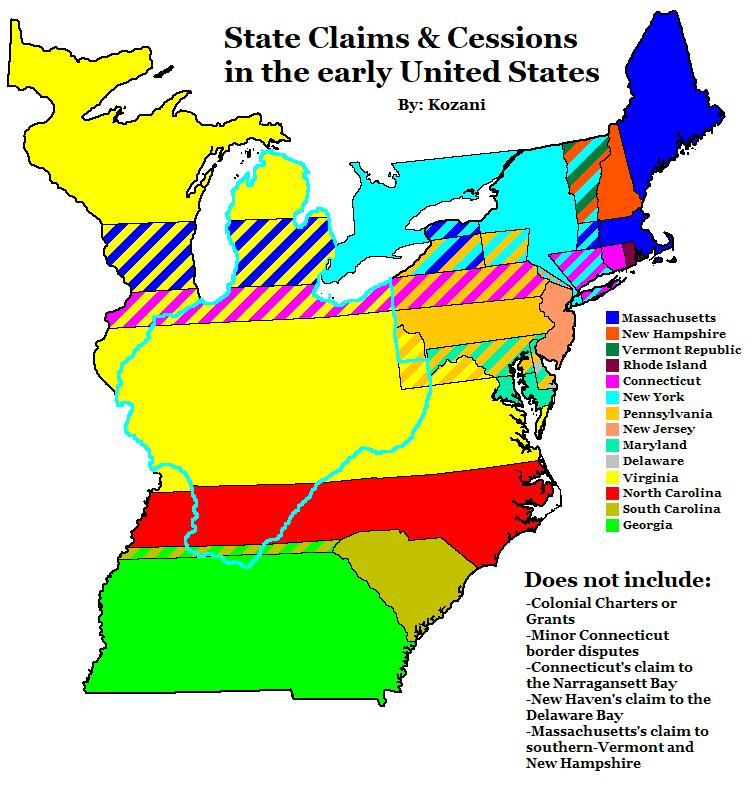Identify some key points in this picture. The color that is used to represent North Carolina is red. 